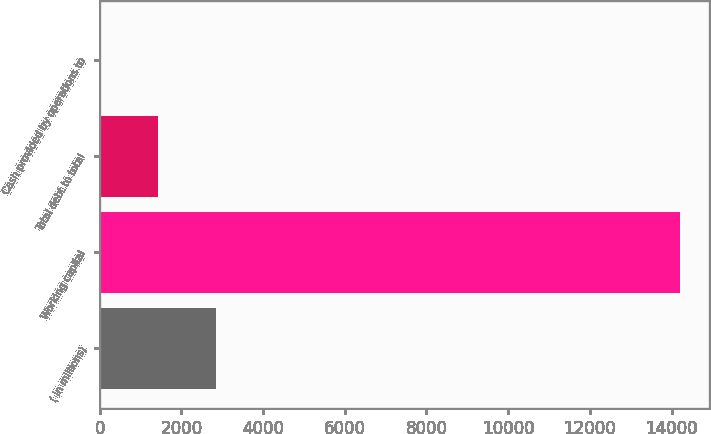Convert chart to OTSL. <chart><loc_0><loc_0><loc_500><loc_500><bar_chart><fcel>( in millions)<fcel>Working capital<fcel>Total debt to total<fcel>Cash provided by operations to<nl><fcel>2841.93<fcel>14208<fcel>1421.17<fcel>0.41<nl></chart> 